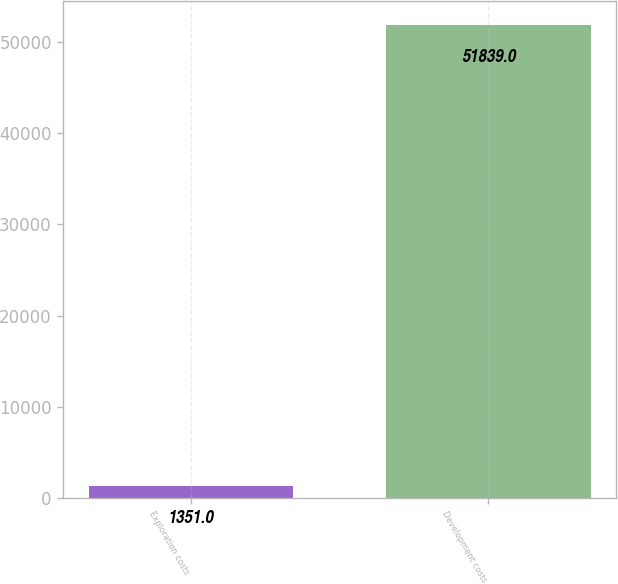Convert chart. <chart><loc_0><loc_0><loc_500><loc_500><bar_chart><fcel>Exploration costs<fcel>Development costs<nl><fcel>1351<fcel>51839<nl></chart> 